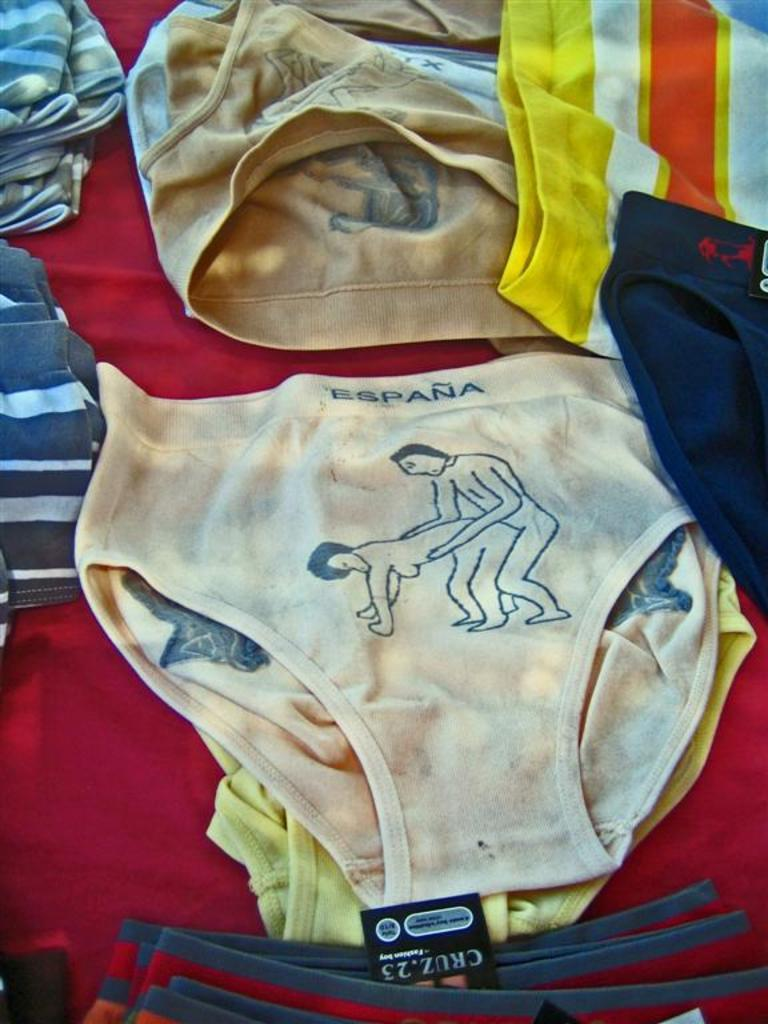Provide a one-sentence caption for the provided image. Espana underwear with a man and woman picture and cruz underwear. 